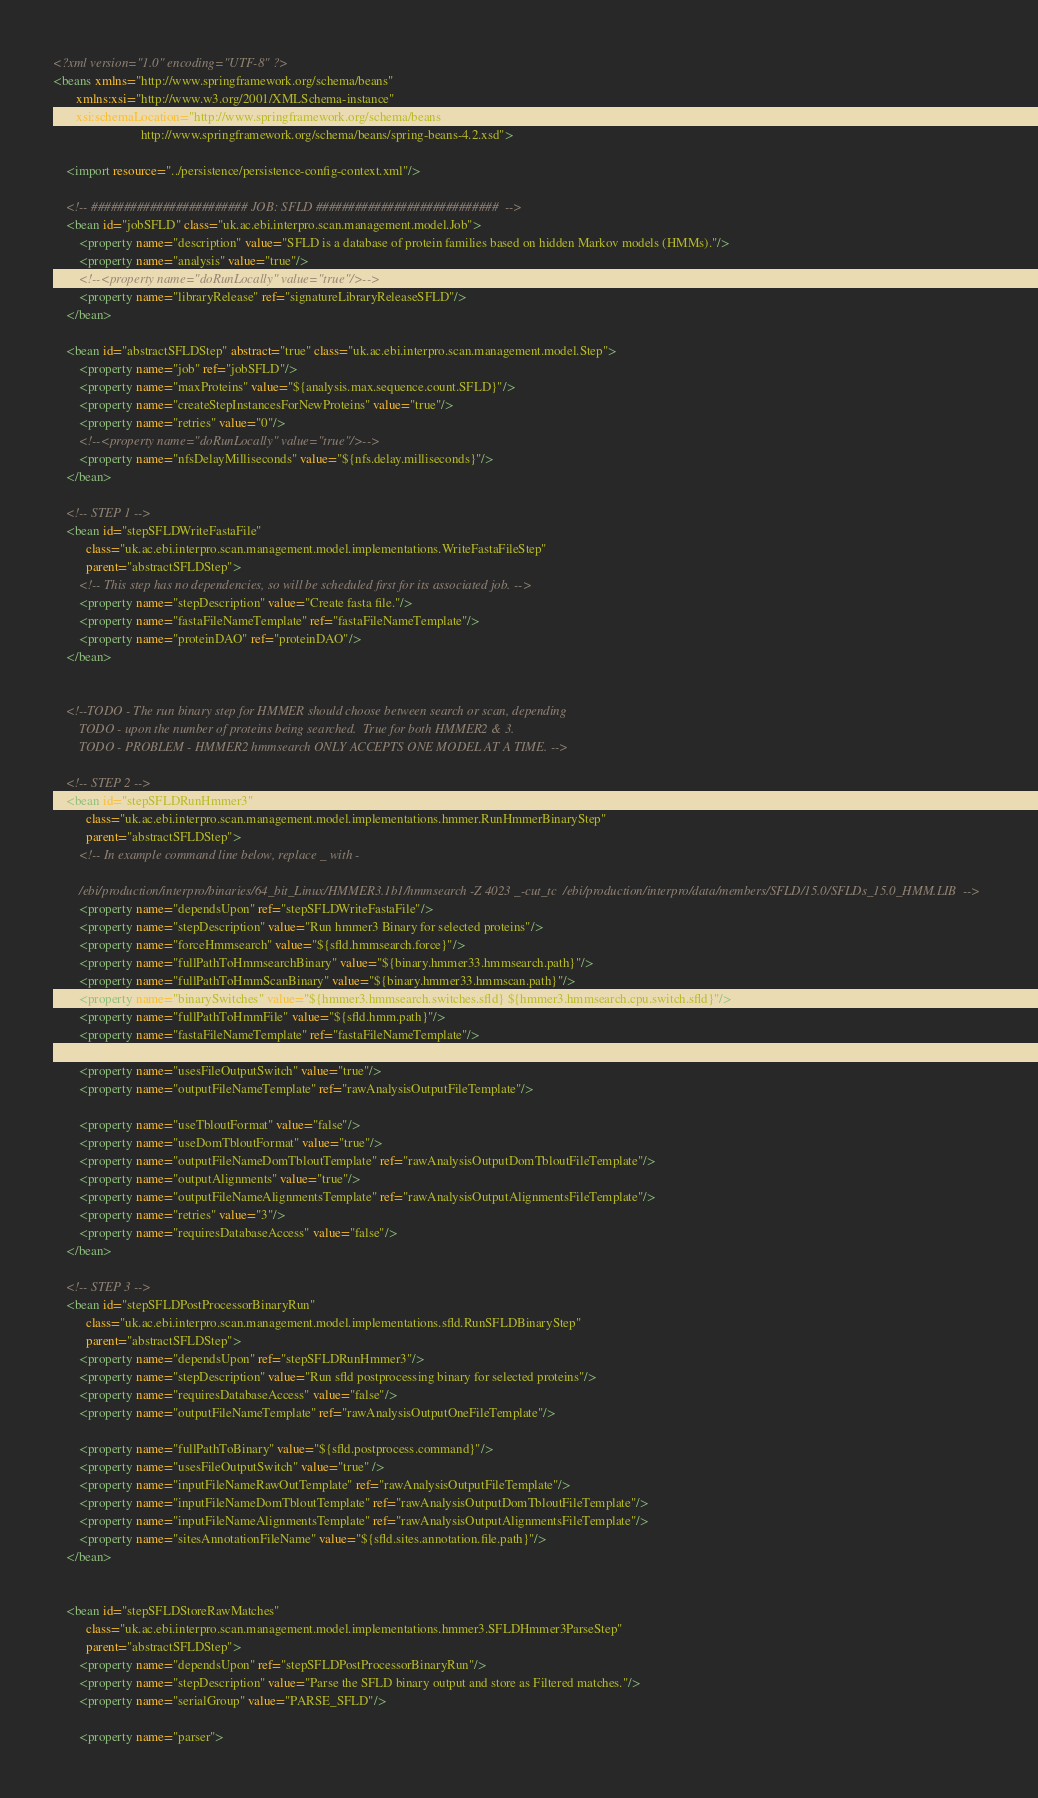<code> <loc_0><loc_0><loc_500><loc_500><_XML_><?xml version="1.0" encoding="UTF-8" ?>
<beans xmlns="http://www.springframework.org/schema/beans"
       xmlns:xsi="http://www.w3.org/2001/XMLSchema-instance"
       xsi:schemaLocation="http://www.springframework.org/schema/beans
                           http://www.springframework.org/schema/beans/spring-beans-4.2.xsd">

    <import resource="../persistence/persistence-config-context.xml"/>

    <!-- ######################## JOB: SFLD ############################  -->
    <bean id="jobSFLD" class="uk.ac.ebi.interpro.scan.management.model.Job">
        <property name="description" value="SFLD is a database of protein families based on hidden Markov models (HMMs)."/>
        <property name="analysis" value="true"/>
        <!--<property name="doRunLocally" value="true"/>-->
        <property name="libraryRelease" ref="signatureLibraryReleaseSFLD"/>
    </bean>

    <bean id="abstractSFLDStep" abstract="true" class="uk.ac.ebi.interpro.scan.management.model.Step">
        <property name="job" ref="jobSFLD"/>
        <property name="maxProteins" value="${analysis.max.sequence.count.SFLD}"/>
        <property name="createStepInstancesForNewProteins" value="true"/>
        <property name="retries" value="0"/>
        <!--<property name="doRunLocally" value="true"/>-->
        <property name="nfsDelayMilliseconds" value="${nfs.delay.milliseconds}"/>
    </bean>

    <!-- STEP 1 -->
    <bean id="stepSFLDWriteFastaFile"
          class="uk.ac.ebi.interpro.scan.management.model.implementations.WriteFastaFileStep"
          parent="abstractSFLDStep">
        <!-- This step has no dependencies, so will be scheduled first for its associated job. -->
        <property name="stepDescription" value="Create fasta file."/>
        <property name="fastaFileNameTemplate" ref="fastaFileNameTemplate"/>
        <property name="proteinDAO" ref="proteinDAO"/>
    </bean>


    <!--TODO - The run binary step for HMMER should choose between search or scan, depending
        TODO - upon the number of proteins being searched.  True for both HMMER2 & 3.
        TODO - PROBLEM - HMMER2 hmmsearch ONLY ACCEPTS ONE MODEL AT A TIME. -->

    <!-- STEP 2 -->
    <bean id="stepSFLDRunHmmer3"
          class="uk.ac.ebi.interpro.scan.management.model.implementations.hmmer.RunHmmerBinaryStep"
          parent="abstractSFLDStep">
        <!-- In example command line below, replace _ with -
        
        /ebi/production/interpro/binaries/64_bit_Linux/HMMER3.1b1/hmmsearch -Z 4023 _-cut_tc  /ebi/production/interpro/data/members/SFLD/15.0/SFLDs_15.0_HMM.LIB  -->
        <property name="dependsUpon" ref="stepSFLDWriteFastaFile"/>
        <property name="stepDescription" value="Run hmmer3 Binary for selected proteins"/>
        <property name="forceHmmsearch" value="${sfld.hmmsearch.force}"/>
        <property name="fullPathToHmmsearchBinary" value="${binary.hmmer33.hmmsearch.path}"/>
        <property name="fullPathToHmmScanBinary" value="${binary.hmmer33.hmmscan.path}"/>
        <property name="binarySwitches" value="${hmmer3.hmmsearch.switches.sfld} ${hmmer3.hmmsearch.cpu.switch.sfld}"/>
        <property name="fullPathToHmmFile" value="${sfld.hmm.path}"/>
        <property name="fastaFileNameTemplate" ref="fastaFileNameTemplate"/>

        <property name="usesFileOutputSwitch" value="true"/>
        <property name="outputFileNameTemplate" ref="rawAnalysisOutputFileTemplate"/>

        <property name="useTbloutFormat" value="false"/>
        <property name="useDomTbloutFormat" value="true"/>
        <property name="outputFileNameDomTbloutTemplate" ref="rawAnalysisOutputDomTbloutFileTemplate"/>
        <property name="outputAlignments" value="true"/>
        <property name="outputFileNameAlignmentsTemplate" ref="rawAnalysisOutputAlignmentsFileTemplate"/>
        <property name="retries" value="3"/>
        <property name="requiresDatabaseAccess" value="false"/>
    </bean>

    <!-- STEP 3 -->
    <bean id="stepSFLDPostProcessorBinaryRun"
          class="uk.ac.ebi.interpro.scan.management.model.implementations.sfld.RunSFLDBinaryStep"
          parent="abstractSFLDStep">
        <property name="dependsUpon" ref="stepSFLDRunHmmer3"/>
        <property name="stepDescription" value="Run sfld postprocessing binary for selected proteins"/>
        <property name="requiresDatabaseAccess" value="false"/>
        <property name="outputFileNameTemplate" ref="rawAnalysisOutputOneFileTemplate"/>

        <property name="fullPathToBinary" value="${sfld.postprocess.command}"/>
        <property name="usesFileOutputSwitch" value="true" />
        <property name="inputFileNameRawOutTemplate" ref="rawAnalysisOutputFileTemplate"/>
        <property name="inputFileNameDomTbloutTemplate" ref="rawAnalysisOutputDomTbloutFileTemplate"/>
        <property name="inputFileNameAlignmentsTemplate" ref="rawAnalysisOutputAlignmentsFileTemplate"/>
        <property name="sitesAnnotationFileName" value="${sfld.sites.annotation.file.path}"/>
    </bean>


    <bean id="stepSFLDStoreRawMatches"
          class="uk.ac.ebi.interpro.scan.management.model.implementations.hmmer3.SFLDHmmer3ParseStep"
          parent="abstractSFLDStep">
        <property name="dependsUpon" ref="stepSFLDPostProcessorBinaryRun"/>
        <property name="stepDescription" value="Parse the SFLD binary output and store as Filtered matches."/>
        <property name="serialGroup" value="PARSE_SFLD"/>
        
        <property name="parser"></code> 